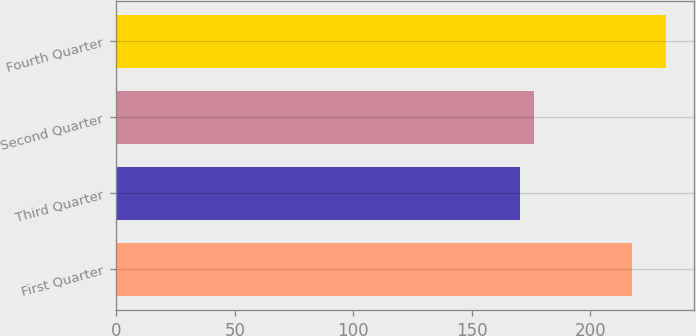Convert chart. <chart><loc_0><loc_0><loc_500><loc_500><bar_chart><fcel>First Quarter<fcel>Third Quarter<fcel>Second Quarter<fcel>Fourth Quarter<nl><fcel>217.76<fcel>170.25<fcel>176.44<fcel>232.2<nl></chart> 